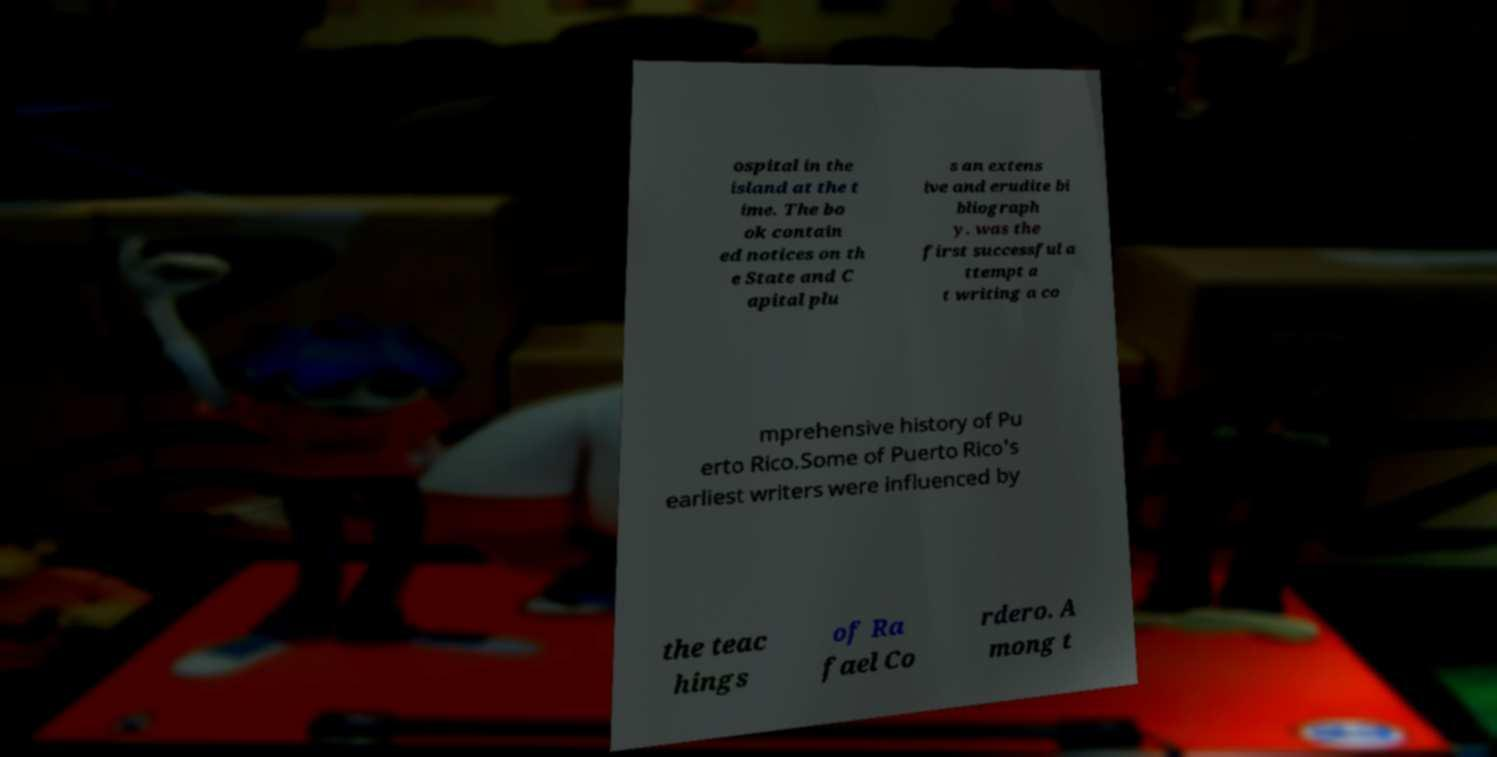Can you read and provide the text displayed in the image?This photo seems to have some interesting text. Can you extract and type it out for me? ospital in the island at the t ime. The bo ok contain ed notices on th e State and C apital plu s an extens ive and erudite bi bliograph y. was the first successful a ttempt a t writing a co mprehensive history of Pu erto Rico.Some of Puerto Rico's earliest writers were influenced by the teac hings of Ra fael Co rdero. A mong t 